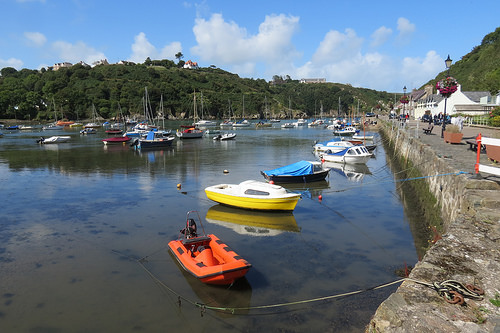<image>
Can you confirm if the boat is under the water? No. The boat is not positioned under the water. The vertical relationship between these objects is different. 